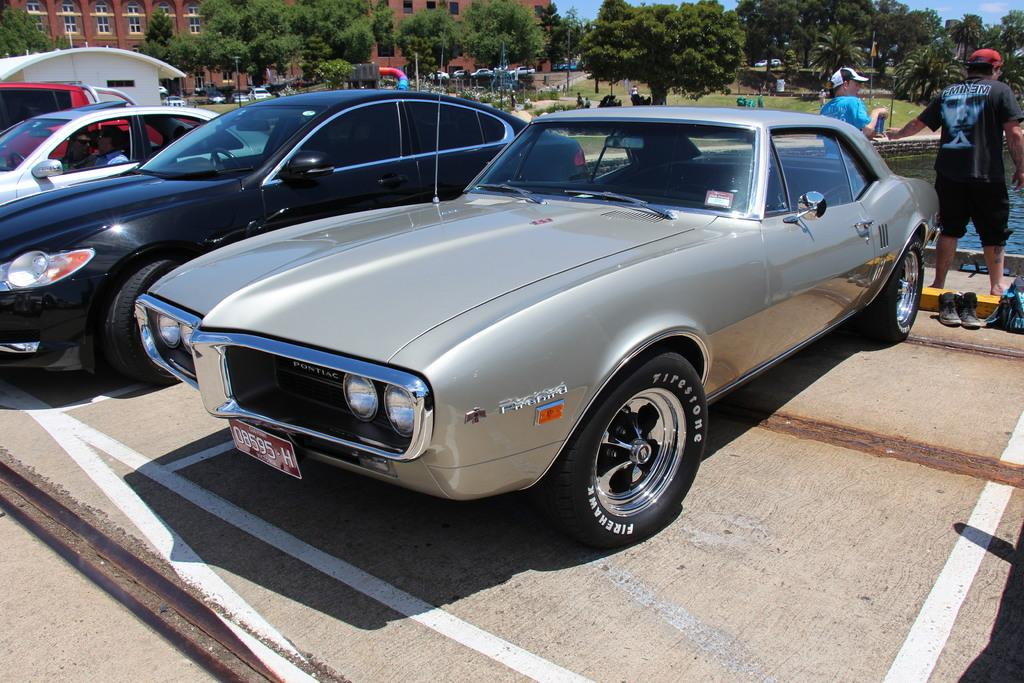What can be seen in large numbers in the image? There are many vehicles in the image. Where are the two people wearing caps located in the image? The two people wearing caps are on the right side of the image. What is on the ground in the image? There are shoes on the ground in the image. What can be seen in the distance in the image? There are trees and a building with windows in the background of the image. What type of polish is being applied to the vehicles in the image? There is no indication in the image that any polish is being applied to the vehicles. Can you describe the breath of the people in the image? There are no people visible in the image, so it is impossible to describe their breath. 